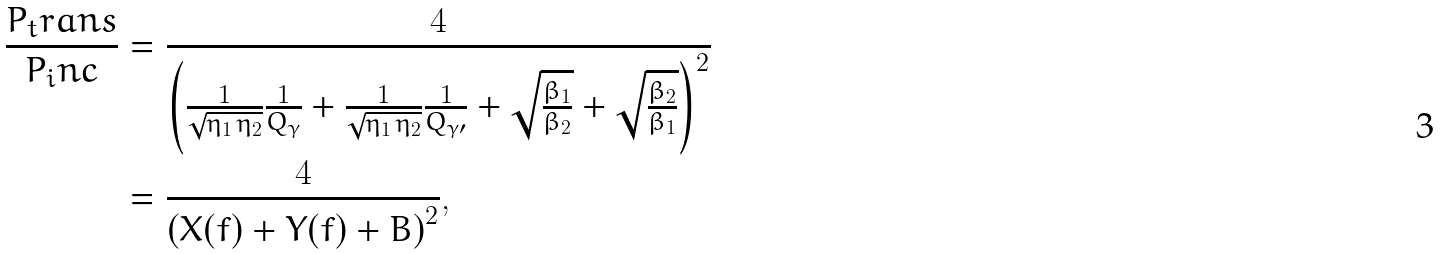<formula> <loc_0><loc_0><loc_500><loc_500>\frac { P _ { t } r a n s } { P _ { i } n c } & = \frac { 4 } { \left ( \frac { 1 } { \sqrt { \eta _ { 1 } \, \eta _ { 2 } } } \frac { 1 } { Q _ { \gamma } } + \frac { 1 } { \sqrt { \eta _ { 1 } \, \eta _ { 2 } } } \frac { 1 } { Q _ { \gamma \prime } } + \sqrt { \frac { \beta _ { 1 } } { \beta _ { 2 } } } + \sqrt { \frac { \beta _ { 2 } } { \beta _ { 1 } } } \right ) ^ { 2 } } \\ & = \frac { 4 } { \left ( X ( f ) + Y ( f ) + B \right ) ^ { 2 } } ,</formula> 